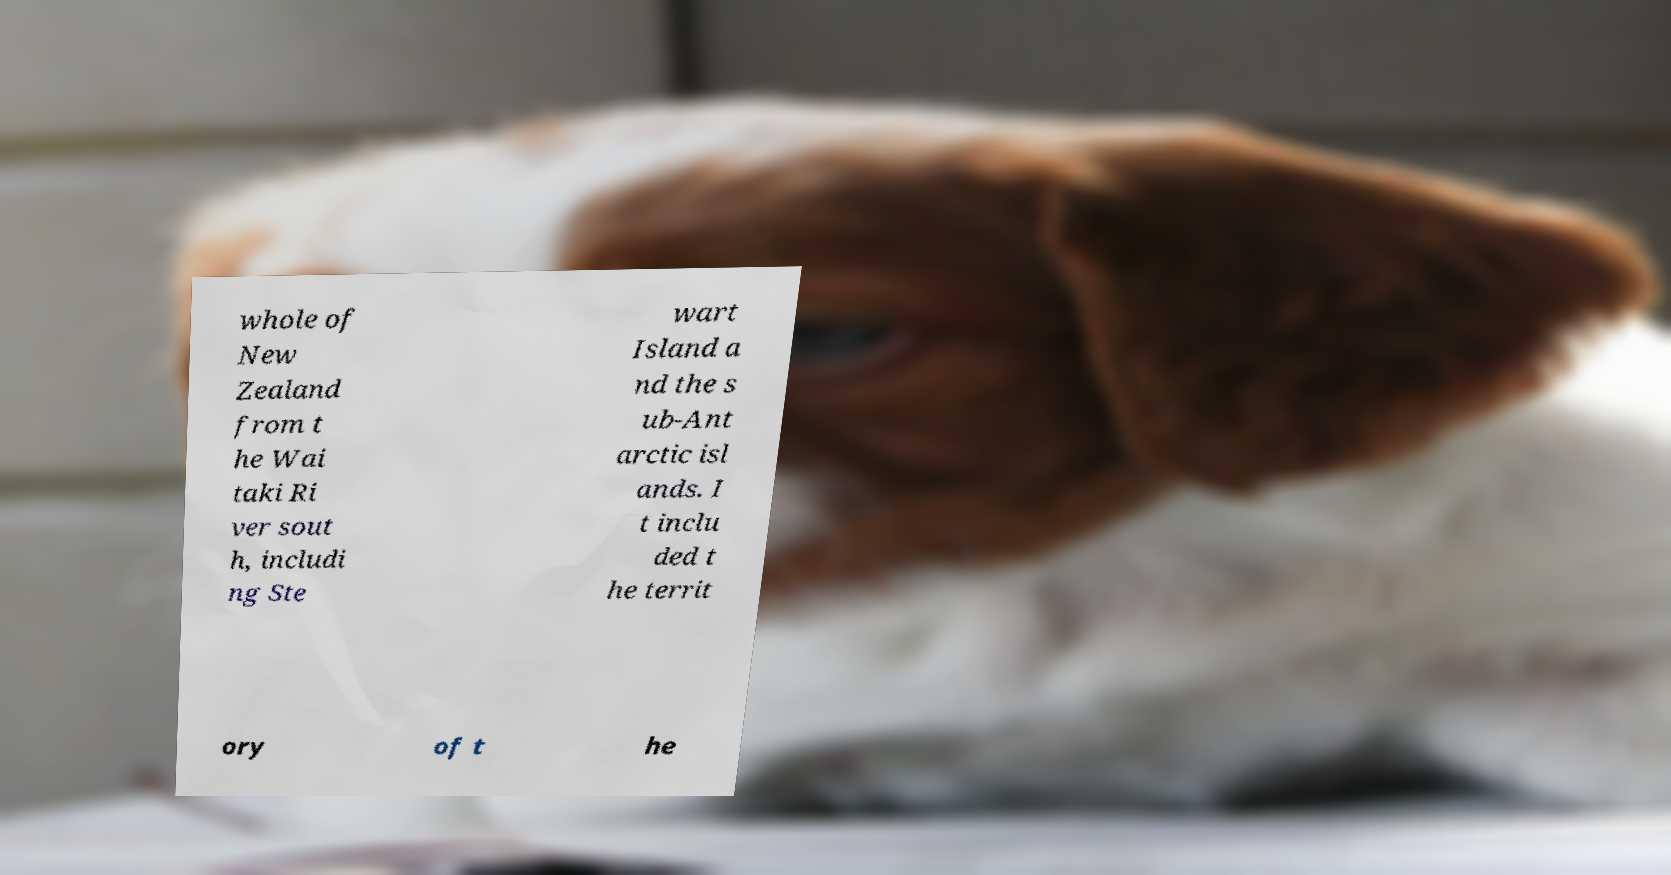I need the written content from this picture converted into text. Can you do that? whole of New Zealand from t he Wai taki Ri ver sout h, includi ng Ste wart Island a nd the s ub-Ant arctic isl ands. I t inclu ded t he territ ory of t he 